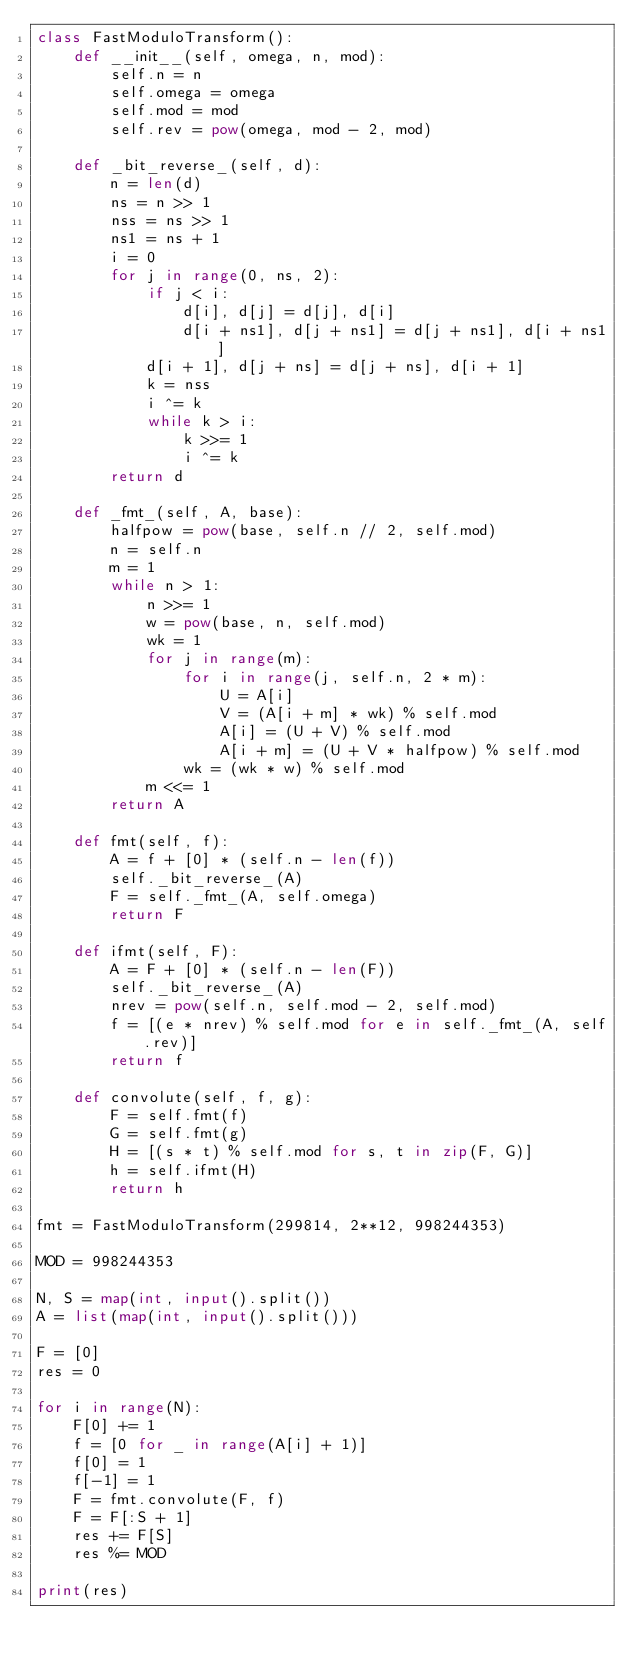Convert code to text. <code><loc_0><loc_0><loc_500><loc_500><_Python_>class FastModuloTransform():
    def __init__(self, omega, n, mod):
        self.n = n
        self.omega = omega
        self.mod = mod
        self.rev = pow(omega, mod - 2, mod)

    def _bit_reverse_(self, d):
        n = len(d)
        ns = n >> 1
        nss = ns >> 1
        ns1 = ns + 1
        i = 0
        for j in range(0, ns, 2):
            if j < i:
                d[i], d[j] = d[j], d[i]
                d[i + ns1], d[j + ns1] = d[j + ns1], d[i + ns1]
            d[i + 1], d[j + ns] = d[j + ns], d[i + 1]
            k = nss
            i ^= k
            while k > i:
                k >>= 1
                i ^= k
        return d

    def _fmt_(self, A, base):
        halfpow = pow(base, self.n // 2, self.mod)
        n = self.n
        m = 1
        while n > 1:
            n >>= 1
            w = pow(base, n, self.mod)
            wk = 1
            for j in range(m):
                for i in range(j, self.n, 2 * m):
                    U = A[i]
                    V = (A[i + m] * wk) % self.mod
                    A[i] = (U + V) % self.mod
                    A[i + m] = (U + V * halfpow) % self.mod
                wk = (wk * w) % self.mod
            m <<= 1
        return A

    def fmt(self, f):
        A = f + [0] * (self.n - len(f))
        self._bit_reverse_(A)
        F = self._fmt_(A, self.omega)
        return F

    def ifmt(self, F):
        A = F + [0] * (self.n - len(F))
        self._bit_reverse_(A)
        nrev = pow(self.n, self.mod - 2, self.mod)
        f = [(e * nrev) % self.mod for e in self._fmt_(A, self.rev)]
        return f

    def convolute(self, f, g):
        F = self.fmt(f)
        G = self.fmt(g)
        H = [(s * t) % self.mod for s, t in zip(F, G)]
        h = self.ifmt(H)
        return h

fmt = FastModuloTransform(299814, 2**12, 998244353)

MOD = 998244353

N, S = map(int, input().split())
A = list(map(int, input().split()))

F = [0]
res = 0

for i in range(N):
    F[0] += 1
    f = [0 for _ in range(A[i] + 1)]
    f[0] = 1
    f[-1] = 1
    F = fmt.convolute(F, f)
    F = F[:S + 1]
    res += F[S]
    res %= MOD

print(res)</code> 